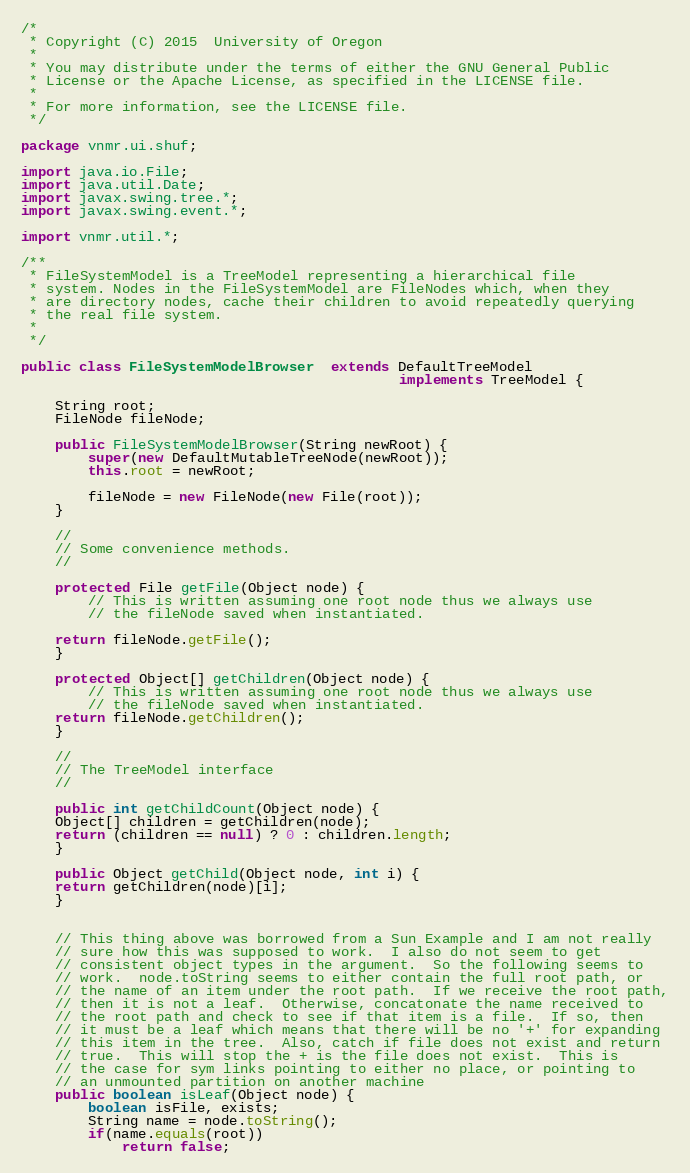Convert code to text. <code><loc_0><loc_0><loc_500><loc_500><_Java_>/*
 * Copyright (C) 2015  University of Oregon
 *
 * You may distribute under the terms of either the GNU General Public
 * License or the Apache License, as specified in the LICENSE file.
 *
 * For more information, see the LICENSE file.
 */

package vnmr.ui.shuf;

import java.io.File;
import java.util.Date;
import javax.swing.tree.*;
import javax.swing.event.*;

import vnmr.util.*;

/**
 * FileSystemModel is a TreeModel representing a hierarchical file 
 * system. Nodes in the FileSystemModel are FileNodes which, when they 
 * are directory nodes, cache their children to avoid repeatedly querying 
 * the real file system. 
 * 
 */

public class FileSystemModelBrowser  extends DefaultTreeModel 
                                             implements TreeModel {

    String root;
    FileNode fileNode;

    public FileSystemModelBrowser(String newRoot) { 
        super(new DefaultMutableTreeNode(newRoot));
        this.root = newRoot;

        fileNode = new FileNode(new File(root)); 
    }

    //
    // Some convenience methods. 
    //

    protected File getFile(Object node) {
        // This is written assuming one root node thus we always use
        // the fileNode saved when instantiated.

	return fileNode.getFile();       
    }

    protected Object[] getChildren(Object node) {
        // This is written assuming one root node thus we always use
        // the fileNode saved when instantiated.
	return fileNode.getChildren(); 
    }

    //
    // The TreeModel interface
    //

    public int getChildCount(Object node) { 
	Object[] children = getChildren(node); 
	return (children == null) ? 0 : children.length;
    }

    public Object getChild(Object node, int i) { 
	return getChildren(node)[i]; 
    }


    // This thing above was borrowed from a Sun Example and I am not really 
    // sure how this was supposed to work.  I also do not seem to get
    // consistent object types in the argument.  So the following seems to
    // work.  node.toString seems to either contain the full root path, or
    // the name of an item under the root path.  If we receive the root path,
    // then it is not a leaf.  Otherwise, concatonate the name received to
    // the root path and check to see if that item is a file.  If so, then
    // it must be a leaf which means that there will be no '+' for expanding
    // this item in the tree.  Also, catch if file does not exist and return
    // true.  This will stop the + is the file does not exist.  This is 
    // the case for sym links pointing to either no place, or pointing to
    // an unmounted partition on another machine
    public boolean isLeaf(Object node) { 
        boolean isFile, exists;
        String name = node.toString();
        if(name.equals(root))
            return false;
</code> 